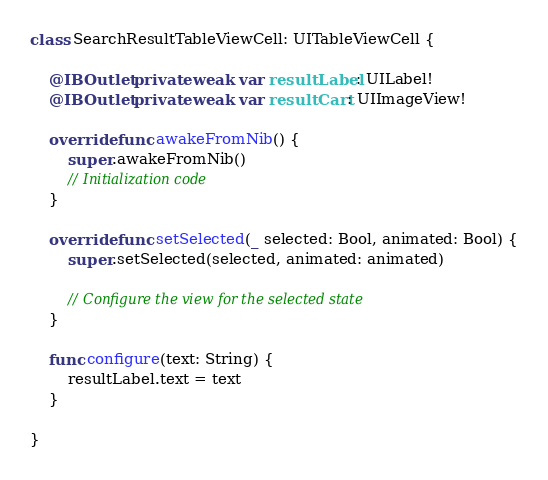Convert code to text. <code><loc_0><loc_0><loc_500><loc_500><_Swift_>class SearchResultTableViewCell: UITableViewCell {
    
    @IBOutlet private weak var resultLabel: UILabel!
    @IBOutlet private weak var resultCart: UIImageView!
    
    override func awakeFromNib() {
        super.awakeFromNib()
        // Initialization code
    }

    override func setSelected(_ selected: Bool, animated: Bool) {
        super.setSelected(selected, animated: animated)

        // Configure the view for the selected state
    }

    func configure(text: String) {
        resultLabel.text = text
    }

}
</code> 